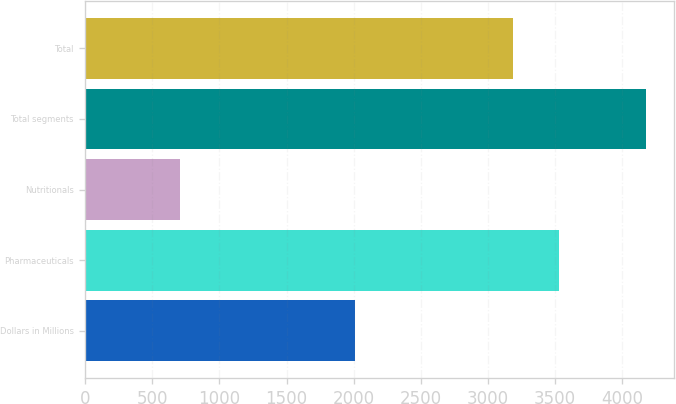Convert chart to OTSL. <chart><loc_0><loc_0><loc_500><loc_500><bar_chart><fcel>Dollars in Millions<fcel>Pharmaceuticals<fcel>Nutritionals<fcel>Total segments<fcel>Total<nl><fcel>2007<fcel>3533.1<fcel>708<fcel>4179<fcel>3186<nl></chart> 